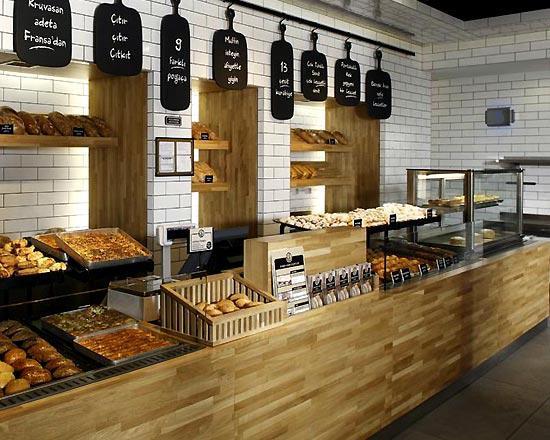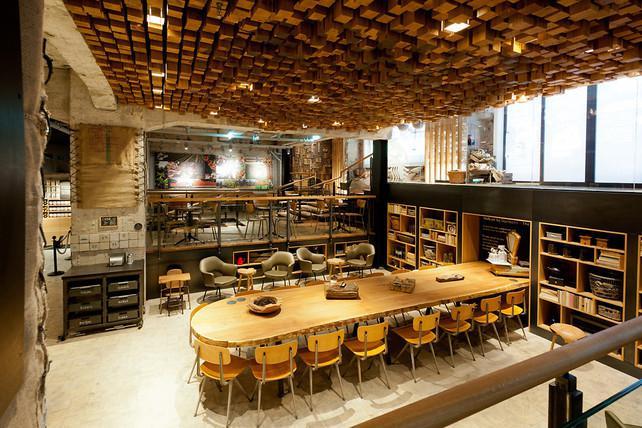The first image is the image on the left, the second image is the image on the right. For the images displayed, is the sentence "One image shows a food establishment with a geometric pattern, black and white floor." factually correct? Answer yes or no. No. The first image is the image on the left, the second image is the image on the right. Examine the images to the left and right. Is the description "there are chairs in the image on the right." accurate? Answer yes or no. Yes. 